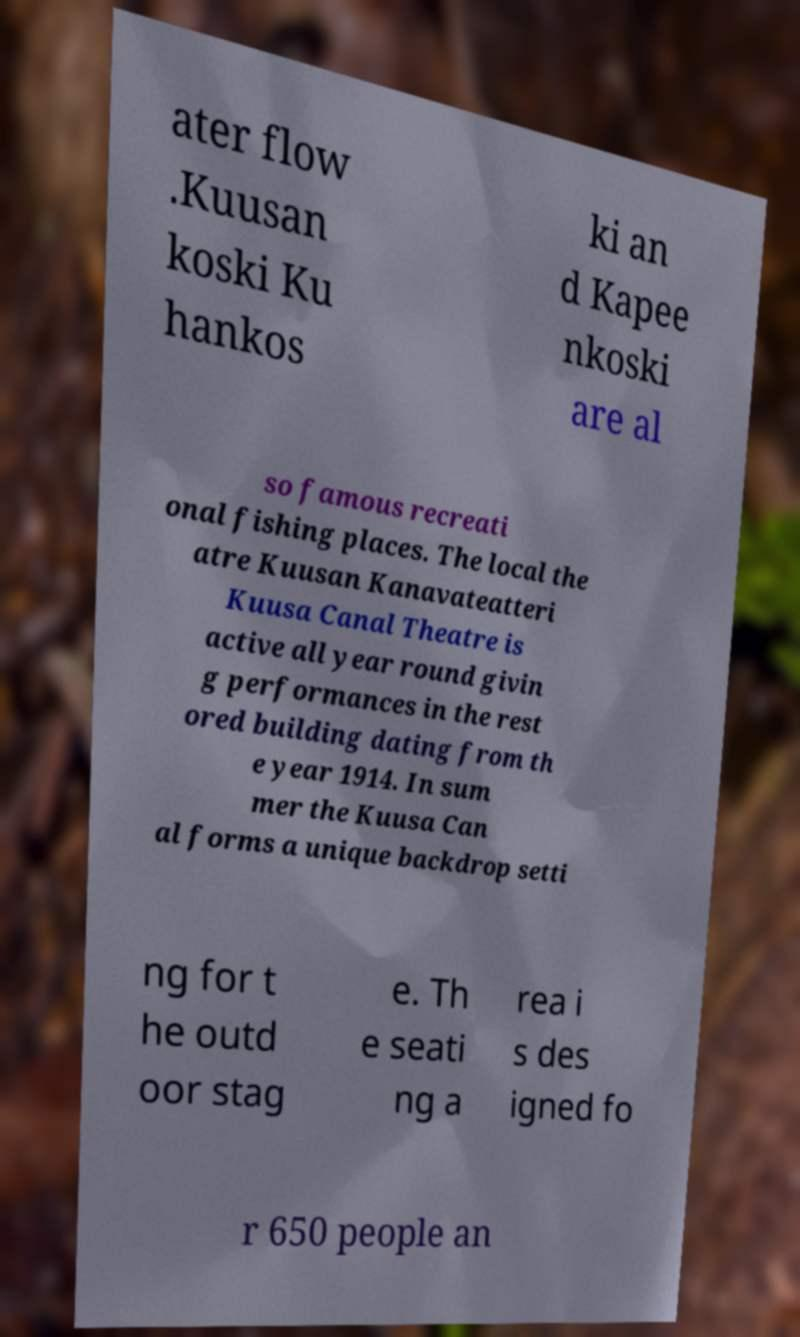Please read and relay the text visible in this image. What does it say? ater flow .Kuusan koski Ku hankos ki an d Kapee nkoski are al so famous recreati onal fishing places. The local the atre Kuusan Kanavateatteri Kuusa Canal Theatre is active all year round givin g performances in the rest ored building dating from th e year 1914. In sum mer the Kuusa Can al forms a unique backdrop setti ng for t he outd oor stag e. Th e seati ng a rea i s des igned fo r 650 people an 